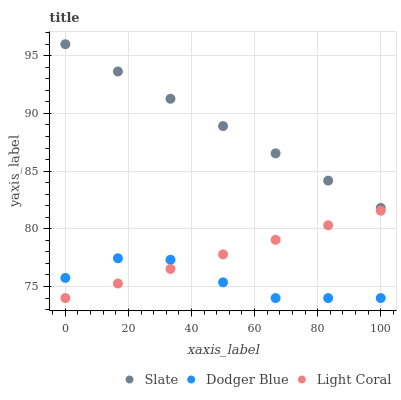Does Dodger Blue have the minimum area under the curve?
Answer yes or no. Yes. Does Slate have the maximum area under the curve?
Answer yes or no. Yes. Does Slate have the minimum area under the curve?
Answer yes or no. No. Does Dodger Blue have the maximum area under the curve?
Answer yes or no. No. Is Light Coral the smoothest?
Answer yes or no. Yes. Is Dodger Blue the roughest?
Answer yes or no. Yes. Is Slate the smoothest?
Answer yes or no. No. Is Slate the roughest?
Answer yes or no. No. Does Light Coral have the lowest value?
Answer yes or no. Yes. Does Slate have the lowest value?
Answer yes or no. No. Does Slate have the highest value?
Answer yes or no. Yes. Does Dodger Blue have the highest value?
Answer yes or no. No. Is Dodger Blue less than Slate?
Answer yes or no. Yes. Is Slate greater than Dodger Blue?
Answer yes or no. Yes. Does Dodger Blue intersect Light Coral?
Answer yes or no. Yes. Is Dodger Blue less than Light Coral?
Answer yes or no. No. Is Dodger Blue greater than Light Coral?
Answer yes or no. No. Does Dodger Blue intersect Slate?
Answer yes or no. No. 